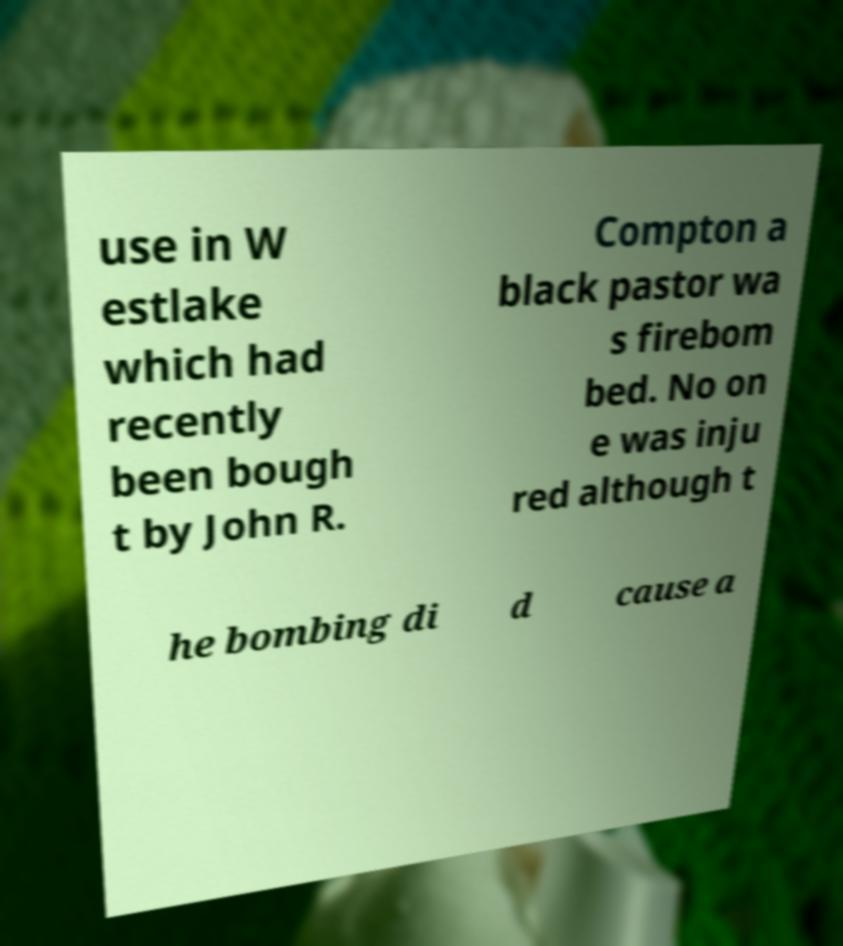Could you extract and type out the text from this image? use in W estlake which had recently been bough t by John R. Compton a black pastor wa s firebom bed. No on e was inju red although t he bombing di d cause a 